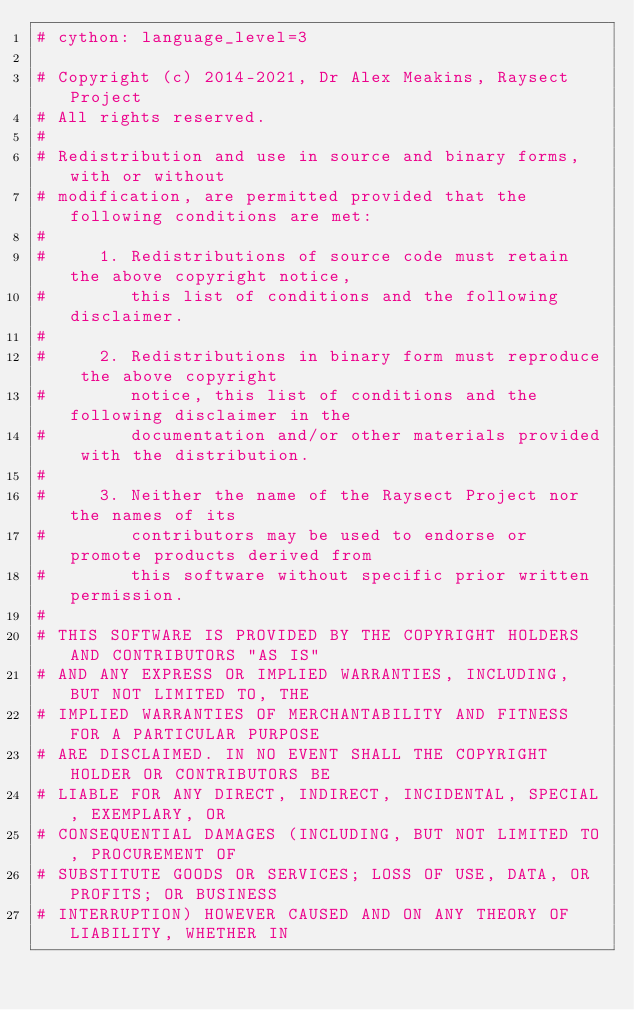Convert code to text. <code><loc_0><loc_0><loc_500><loc_500><_Cython_># cython: language_level=3

# Copyright (c) 2014-2021, Dr Alex Meakins, Raysect Project
# All rights reserved.
#
# Redistribution and use in source and binary forms, with or without
# modification, are permitted provided that the following conditions are met:
#
#     1. Redistributions of source code must retain the above copyright notice,
#        this list of conditions and the following disclaimer.
#
#     2. Redistributions in binary form must reproduce the above copyright
#        notice, this list of conditions and the following disclaimer in the
#        documentation and/or other materials provided with the distribution.
#
#     3. Neither the name of the Raysect Project nor the names of its
#        contributors may be used to endorse or promote products derived from
#        this software without specific prior written permission.
#
# THIS SOFTWARE IS PROVIDED BY THE COPYRIGHT HOLDERS AND CONTRIBUTORS "AS IS"
# AND ANY EXPRESS OR IMPLIED WARRANTIES, INCLUDING, BUT NOT LIMITED TO, THE
# IMPLIED WARRANTIES OF MERCHANTABILITY AND FITNESS FOR A PARTICULAR PURPOSE
# ARE DISCLAIMED. IN NO EVENT SHALL THE COPYRIGHT HOLDER OR CONTRIBUTORS BE
# LIABLE FOR ANY DIRECT, INDIRECT, INCIDENTAL, SPECIAL, EXEMPLARY, OR
# CONSEQUENTIAL DAMAGES (INCLUDING, BUT NOT LIMITED TO, PROCUREMENT OF
# SUBSTITUTE GOODS OR SERVICES; LOSS OF USE, DATA, OR PROFITS; OR BUSINESS
# INTERRUPTION) HOWEVER CAUSED AND ON ANY THEORY OF LIABILITY, WHETHER IN</code> 